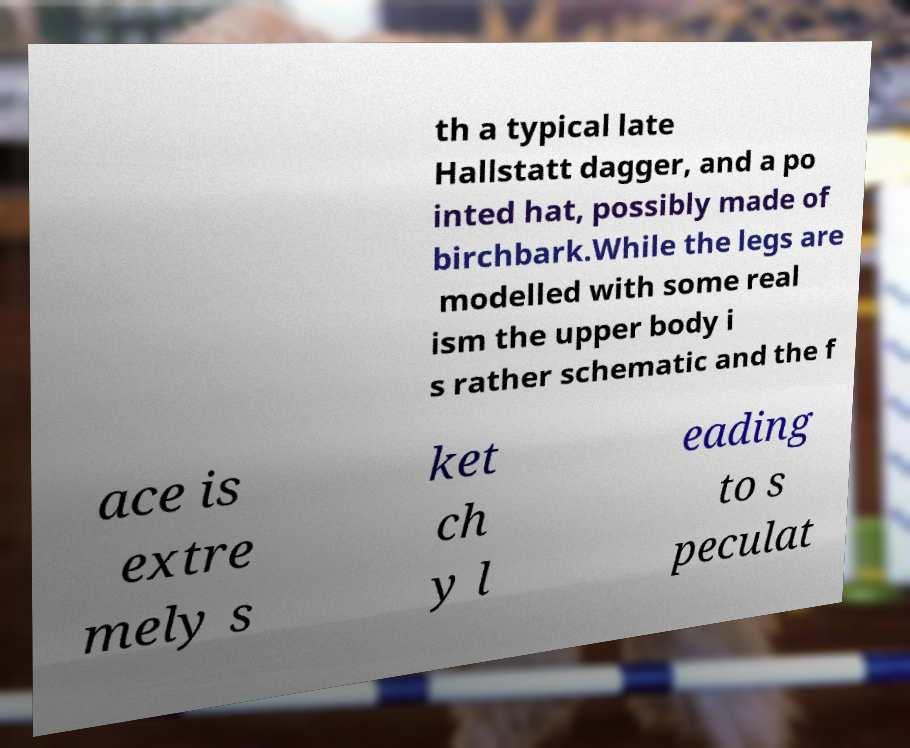What messages or text are displayed in this image? I need them in a readable, typed format. th a typical late Hallstatt dagger, and a po inted hat, possibly made of birchbark.While the legs are modelled with some real ism the upper body i s rather schematic and the f ace is extre mely s ket ch y l eading to s peculat 